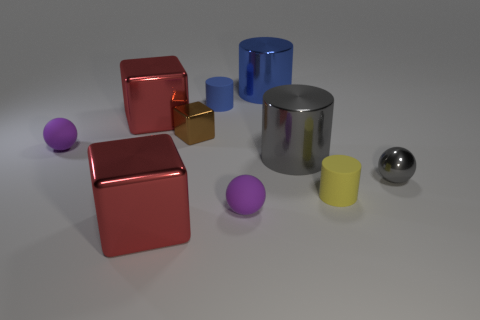Subtract all gray spheres. How many spheres are left? 2 Subtract all gray balls. How many balls are left? 2 Subtract all cylinders. How many objects are left? 6 Add 7 purple matte balls. How many purple matte balls are left? 9 Add 2 small matte things. How many small matte things exist? 6 Subtract 2 purple balls. How many objects are left? 8 Subtract 2 spheres. How many spheres are left? 1 Subtract all purple blocks. Subtract all brown balls. How many blocks are left? 3 Subtract all gray blocks. How many blue cylinders are left? 2 Subtract all red metallic cubes. Subtract all blue cylinders. How many objects are left? 6 